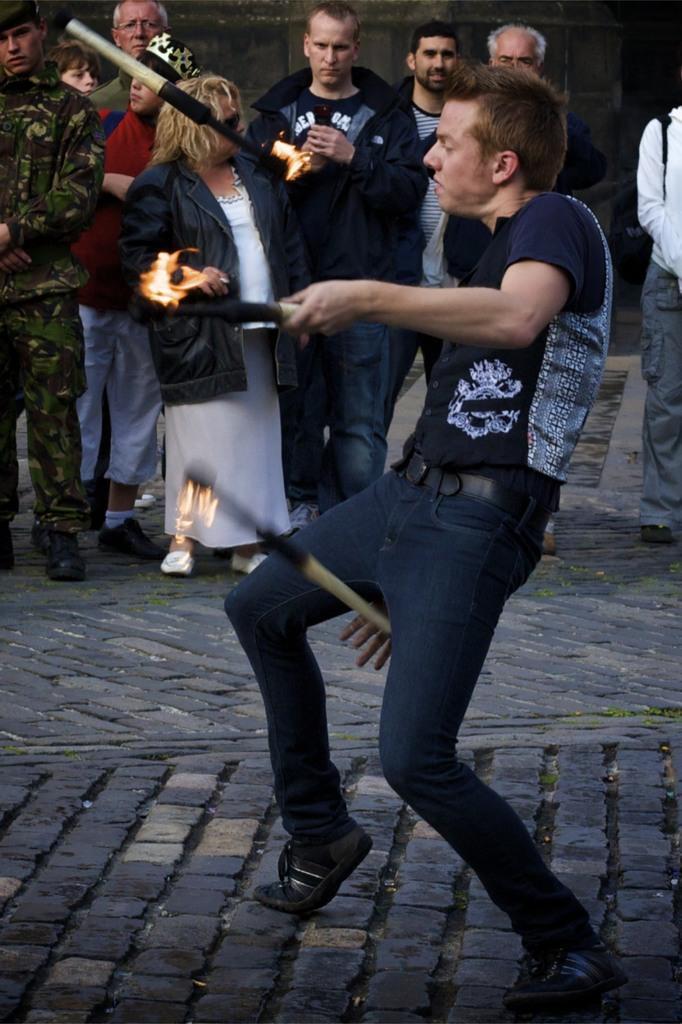Could you give a brief overview of what you see in this image? A man is playing with fire to the sticks on the ground. In the background there are few persons standing on the ground and we can see the wall. 